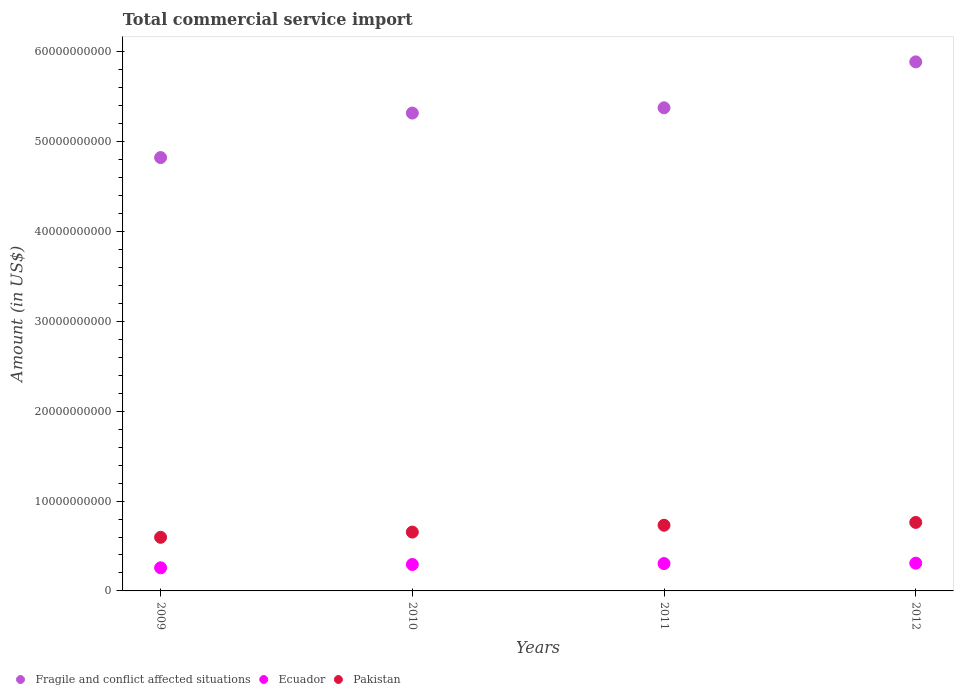How many different coloured dotlines are there?
Provide a short and direct response. 3. What is the total commercial service import in Pakistan in 2010?
Your answer should be compact. 6.55e+09. Across all years, what is the maximum total commercial service import in Ecuador?
Your answer should be compact. 3.09e+09. Across all years, what is the minimum total commercial service import in Ecuador?
Your answer should be compact. 2.57e+09. In which year was the total commercial service import in Fragile and conflict affected situations maximum?
Ensure brevity in your answer.  2012. What is the total total commercial service import in Pakistan in the graph?
Provide a succinct answer. 2.75e+1. What is the difference between the total commercial service import in Ecuador in 2009 and that in 2012?
Ensure brevity in your answer.  -5.16e+08. What is the difference between the total commercial service import in Pakistan in 2011 and the total commercial service import in Fragile and conflict affected situations in 2009?
Keep it short and to the point. -4.09e+1. What is the average total commercial service import in Ecuador per year?
Provide a succinct answer. 2.91e+09. In the year 2009, what is the difference between the total commercial service import in Ecuador and total commercial service import in Fragile and conflict affected situations?
Your answer should be very brief. -4.57e+1. In how many years, is the total commercial service import in Pakistan greater than 26000000000 US$?
Provide a short and direct response. 0. What is the ratio of the total commercial service import in Ecuador in 2009 to that in 2012?
Offer a very short reply. 0.83. Is the total commercial service import in Pakistan in 2010 less than that in 2011?
Your answer should be very brief. Yes. Is the difference between the total commercial service import in Ecuador in 2009 and 2012 greater than the difference between the total commercial service import in Fragile and conflict affected situations in 2009 and 2012?
Make the answer very short. Yes. What is the difference between the highest and the second highest total commercial service import in Fragile and conflict affected situations?
Your answer should be compact. 5.11e+09. What is the difference between the highest and the lowest total commercial service import in Fragile and conflict affected situations?
Offer a terse response. 1.07e+1. In how many years, is the total commercial service import in Pakistan greater than the average total commercial service import in Pakistan taken over all years?
Provide a succinct answer. 2. Is it the case that in every year, the sum of the total commercial service import in Pakistan and total commercial service import in Fragile and conflict affected situations  is greater than the total commercial service import in Ecuador?
Your response must be concise. Yes. How many years are there in the graph?
Your response must be concise. 4. Where does the legend appear in the graph?
Your answer should be compact. Bottom left. What is the title of the graph?
Ensure brevity in your answer.  Total commercial service import. What is the label or title of the Y-axis?
Give a very brief answer. Amount (in US$). What is the Amount (in US$) in Fragile and conflict affected situations in 2009?
Provide a succinct answer. 4.82e+1. What is the Amount (in US$) in Ecuador in 2009?
Offer a terse response. 2.57e+09. What is the Amount (in US$) of Pakistan in 2009?
Your answer should be compact. 5.97e+09. What is the Amount (in US$) of Fragile and conflict affected situations in 2010?
Make the answer very short. 5.32e+1. What is the Amount (in US$) of Ecuador in 2010?
Ensure brevity in your answer.  2.94e+09. What is the Amount (in US$) in Pakistan in 2010?
Offer a terse response. 6.55e+09. What is the Amount (in US$) in Fragile and conflict affected situations in 2011?
Ensure brevity in your answer.  5.38e+1. What is the Amount (in US$) of Ecuador in 2011?
Ensure brevity in your answer.  3.05e+09. What is the Amount (in US$) of Pakistan in 2011?
Your answer should be compact. 7.31e+09. What is the Amount (in US$) in Fragile and conflict affected situations in 2012?
Make the answer very short. 5.89e+1. What is the Amount (in US$) in Ecuador in 2012?
Provide a short and direct response. 3.09e+09. What is the Amount (in US$) of Pakistan in 2012?
Your response must be concise. 7.63e+09. Across all years, what is the maximum Amount (in US$) in Fragile and conflict affected situations?
Your answer should be compact. 5.89e+1. Across all years, what is the maximum Amount (in US$) in Ecuador?
Make the answer very short. 3.09e+09. Across all years, what is the maximum Amount (in US$) in Pakistan?
Your answer should be very brief. 7.63e+09. Across all years, what is the minimum Amount (in US$) of Fragile and conflict affected situations?
Ensure brevity in your answer.  4.82e+1. Across all years, what is the minimum Amount (in US$) in Ecuador?
Provide a short and direct response. 2.57e+09. Across all years, what is the minimum Amount (in US$) of Pakistan?
Give a very brief answer. 5.97e+09. What is the total Amount (in US$) of Fragile and conflict affected situations in the graph?
Your answer should be compact. 2.14e+11. What is the total Amount (in US$) in Ecuador in the graph?
Your response must be concise. 1.17e+1. What is the total Amount (in US$) of Pakistan in the graph?
Ensure brevity in your answer.  2.75e+1. What is the difference between the Amount (in US$) of Fragile and conflict affected situations in 2009 and that in 2010?
Your answer should be compact. -4.95e+09. What is the difference between the Amount (in US$) in Ecuador in 2009 and that in 2010?
Your answer should be very brief. -3.67e+08. What is the difference between the Amount (in US$) in Pakistan in 2009 and that in 2010?
Provide a succinct answer. -5.83e+08. What is the difference between the Amount (in US$) of Fragile and conflict affected situations in 2009 and that in 2011?
Offer a terse response. -5.54e+09. What is the difference between the Amount (in US$) of Ecuador in 2009 and that in 2011?
Your answer should be very brief. -4.72e+08. What is the difference between the Amount (in US$) in Pakistan in 2009 and that in 2011?
Your response must be concise. -1.35e+09. What is the difference between the Amount (in US$) of Fragile and conflict affected situations in 2009 and that in 2012?
Make the answer very short. -1.07e+1. What is the difference between the Amount (in US$) in Ecuador in 2009 and that in 2012?
Provide a succinct answer. -5.16e+08. What is the difference between the Amount (in US$) in Pakistan in 2009 and that in 2012?
Provide a succinct answer. -1.66e+09. What is the difference between the Amount (in US$) of Fragile and conflict affected situations in 2010 and that in 2011?
Make the answer very short. -5.87e+08. What is the difference between the Amount (in US$) of Ecuador in 2010 and that in 2011?
Provide a succinct answer. -1.05e+08. What is the difference between the Amount (in US$) in Pakistan in 2010 and that in 2011?
Keep it short and to the point. -7.63e+08. What is the difference between the Amount (in US$) of Fragile and conflict affected situations in 2010 and that in 2012?
Keep it short and to the point. -5.70e+09. What is the difference between the Amount (in US$) of Ecuador in 2010 and that in 2012?
Ensure brevity in your answer.  -1.48e+08. What is the difference between the Amount (in US$) of Pakistan in 2010 and that in 2012?
Keep it short and to the point. -1.08e+09. What is the difference between the Amount (in US$) of Fragile and conflict affected situations in 2011 and that in 2012?
Your answer should be very brief. -5.11e+09. What is the difference between the Amount (in US$) of Ecuador in 2011 and that in 2012?
Keep it short and to the point. -4.35e+07. What is the difference between the Amount (in US$) in Pakistan in 2011 and that in 2012?
Keep it short and to the point. -3.13e+08. What is the difference between the Amount (in US$) in Fragile and conflict affected situations in 2009 and the Amount (in US$) in Ecuador in 2010?
Ensure brevity in your answer.  4.53e+1. What is the difference between the Amount (in US$) in Fragile and conflict affected situations in 2009 and the Amount (in US$) in Pakistan in 2010?
Your response must be concise. 4.17e+1. What is the difference between the Amount (in US$) of Ecuador in 2009 and the Amount (in US$) of Pakistan in 2010?
Offer a very short reply. -3.98e+09. What is the difference between the Amount (in US$) of Fragile and conflict affected situations in 2009 and the Amount (in US$) of Ecuador in 2011?
Give a very brief answer. 4.52e+1. What is the difference between the Amount (in US$) in Fragile and conflict affected situations in 2009 and the Amount (in US$) in Pakistan in 2011?
Offer a terse response. 4.09e+1. What is the difference between the Amount (in US$) of Ecuador in 2009 and the Amount (in US$) of Pakistan in 2011?
Your answer should be very brief. -4.74e+09. What is the difference between the Amount (in US$) of Fragile and conflict affected situations in 2009 and the Amount (in US$) of Ecuador in 2012?
Ensure brevity in your answer.  4.52e+1. What is the difference between the Amount (in US$) in Fragile and conflict affected situations in 2009 and the Amount (in US$) in Pakistan in 2012?
Your answer should be very brief. 4.06e+1. What is the difference between the Amount (in US$) in Ecuador in 2009 and the Amount (in US$) in Pakistan in 2012?
Your answer should be very brief. -5.05e+09. What is the difference between the Amount (in US$) of Fragile and conflict affected situations in 2010 and the Amount (in US$) of Ecuador in 2011?
Ensure brevity in your answer.  5.02e+1. What is the difference between the Amount (in US$) of Fragile and conflict affected situations in 2010 and the Amount (in US$) of Pakistan in 2011?
Keep it short and to the point. 4.59e+1. What is the difference between the Amount (in US$) in Ecuador in 2010 and the Amount (in US$) in Pakistan in 2011?
Make the answer very short. -4.37e+09. What is the difference between the Amount (in US$) of Fragile and conflict affected situations in 2010 and the Amount (in US$) of Ecuador in 2012?
Offer a terse response. 5.01e+1. What is the difference between the Amount (in US$) of Fragile and conflict affected situations in 2010 and the Amount (in US$) of Pakistan in 2012?
Offer a terse response. 4.56e+1. What is the difference between the Amount (in US$) in Ecuador in 2010 and the Amount (in US$) in Pakistan in 2012?
Your response must be concise. -4.69e+09. What is the difference between the Amount (in US$) of Fragile and conflict affected situations in 2011 and the Amount (in US$) of Ecuador in 2012?
Offer a very short reply. 5.07e+1. What is the difference between the Amount (in US$) in Fragile and conflict affected situations in 2011 and the Amount (in US$) in Pakistan in 2012?
Provide a succinct answer. 4.62e+1. What is the difference between the Amount (in US$) of Ecuador in 2011 and the Amount (in US$) of Pakistan in 2012?
Your answer should be very brief. -4.58e+09. What is the average Amount (in US$) of Fragile and conflict affected situations per year?
Your response must be concise. 5.35e+1. What is the average Amount (in US$) of Ecuador per year?
Your response must be concise. 2.91e+09. What is the average Amount (in US$) in Pakistan per year?
Provide a short and direct response. 6.86e+09. In the year 2009, what is the difference between the Amount (in US$) in Fragile and conflict affected situations and Amount (in US$) in Ecuador?
Make the answer very short. 4.57e+1. In the year 2009, what is the difference between the Amount (in US$) in Fragile and conflict affected situations and Amount (in US$) in Pakistan?
Your answer should be very brief. 4.23e+1. In the year 2009, what is the difference between the Amount (in US$) of Ecuador and Amount (in US$) of Pakistan?
Keep it short and to the point. -3.39e+09. In the year 2010, what is the difference between the Amount (in US$) in Fragile and conflict affected situations and Amount (in US$) in Ecuador?
Offer a terse response. 5.03e+1. In the year 2010, what is the difference between the Amount (in US$) of Fragile and conflict affected situations and Amount (in US$) of Pakistan?
Offer a very short reply. 4.66e+1. In the year 2010, what is the difference between the Amount (in US$) in Ecuador and Amount (in US$) in Pakistan?
Offer a very short reply. -3.61e+09. In the year 2011, what is the difference between the Amount (in US$) of Fragile and conflict affected situations and Amount (in US$) of Ecuador?
Provide a short and direct response. 5.07e+1. In the year 2011, what is the difference between the Amount (in US$) of Fragile and conflict affected situations and Amount (in US$) of Pakistan?
Offer a terse response. 4.65e+1. In the year 2011, what is the difference between the Amount (in US$) of Ecuador and Amount (in US$) of Pakistan?
Your answer should be compact. -4.27e+09. In the year 2012, what is the difference between the Amount (in US$) in Fragile and conflict affected situations and Amount (in US$) in Ecuador?
Give a very brief answer. 5.58e+1. In the year 2012, what is the difference between the Amount (in US$) in Fragile and conflict affected situations and Amount (in US$) in Pakistan?
Offer a very short reply. 5.13e+1. In the year 2012, what is the difference between the Amount (in US$) in Ecuador and Amount (in US$) in Pakistan?
Provide a short and direct response. -4.54e+09. What is the ratio of the Amount (in US$) in Fragile and conflict affected situations in 2009 to that in 2010?
Offer a very short reply. 0.91. What is the ratio of the Amount (in US$) of Ecuador in 2009 to that in 2010?
Make the answer very short. 0.88. What is the ratio of the Amount (in US$) in Pakistan in 2009 to that in 2010?
Your answer should be very brief. 0.91. What is the ratio of the Amount (in US$) in Fragile and conflict affected situations in 2009 to that in 2011?
Your answer should be very brief. 0.9. What is the ratio of the Amount (in US$) of Ecuador in 2009 to that in 2011?
Provide a short and direct response. 0.84. What is the ratio of the Amount (in US$) in Pakistan in 2009 to that in 2011?
Make the answer very short. 0.82. What is the ratio of the Amount (in US$) of Fragile and conflict affected situations in 2009 to that in 2012?
Offer a terse response. 0.82. What is the ratio of the Amount (in US$) in Ecuador in 2009 to that in 2012?
Make the answer very short. 0.83. What is the ratio of the Amount (in US$) in Pakistan in 2009 to that in 2012?
Offer a terse response. 0.78. What is the ratio of the Amount (in US$) in Ecuador in 2010 to that in 2011?
Ensure brevity in your answer.  0.97. What is the ratio of the Amount (in US$) of Pakistan in 2010 to that in 2011?
Your response must be concise. 0.9. What is the ratio of the Amount (in US$) of Fragile and conflict affected situations in 2010 to that in 2012?
Give a very brief answer. 0.9. What is the ratio of the Amount (in US$) of Ecuador in 2010 to that in 2012?
Make the answer very short. 0.95. What is the ratio of the Amount (in US$) of Pakistan in 2010 to that in 2012?
Provide a short and direct response. 0.86. What is the ratio of the Amount (in US$) of Fragile and conflict affected situations in 2011 to that in 2012?
Ensure brevity in your answer.  0.91. What is the ratio of the Amount (in US$) in Ecuador in 2011 to that in 2012?
Your response must be concise. 0.99. What is the ratio of the Amount (in US$) in Pakistan in 2011 to that in 2012?
Your answer should be very brief. 0.96. What is the difference between the highest and the second highest Amount (in US$) in Fragile and conflict affected situations?
Provide a short and direct response. 5.11e+09. What is the difference between the highest and the second highest Amount (in US$) of Ecuador?
Your answer should be very brief. 4.35e+07. What is the difference between the highest and the second highest Amount (in US$) in Pakistan?
Your answer should be very brief. 3.13e+08. What is the difference between the highest and the lowest Amount (in US$) of Fragile and conflict affected situations?
Your answer should be very brief. 1.07e+1. What is the difference between the highest and the lowest Amount (in US$) of Ecuador?
Keep it short and to the point. 5.16e+08. What is the difference between the highest and the lowest Amount (in US$) of Pakistan?
Provide a short and direct response. 1.66e+09. 